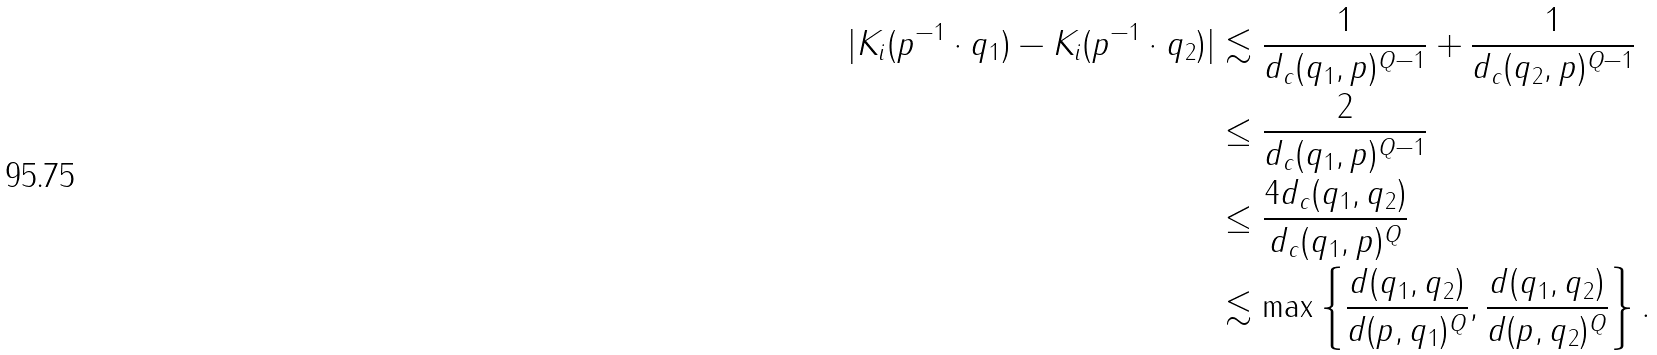Convert formula to latex. <formula><loc_0><loc_0><loc_500><loc_500>| K _ { i } ( p ^ { - 1 } \cdot q _ { 1 } ) - K _ { i } ( p ^ { - 1 } \cdot q _ { 2 } ) | & \lesssim \frac { 1 } { d _ { c } ( q _ { 1 } , p ) ^ { Q - 1 } } + \frac { 1 } { d _ { c } ( q _ { 2 } , p ) ^ { Q - 1 } } \\ & \leq \frac { 2 } { d _ { c } ( q _ { 1 } , p ) ^ { Q - 1 } } \\ & \leq \frac { 4 d _ { c } ( q _ { 1 } , q _ { 2 } ) } { d _ { c } ( q _ { 1 } , p ) ^ { Q } } \\ & \lesssim \max \left \{ \frac { d ( q _ { 1 } , q _ { 2 } ) } { d ( p , q _ { 1 } ) ^ { Q } } , \frac { d ( q _ { 1 } , q _ { 2 } ) } { d ( p , q _ { 2 } ) ^ { Q } } \right \} .</formula> 